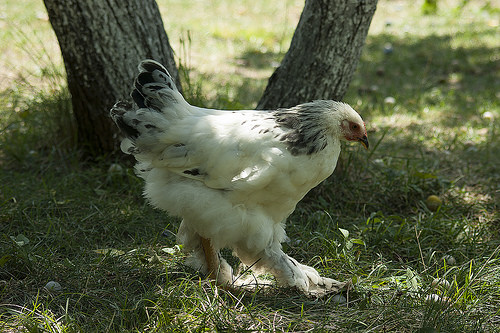<image>
Is there a tree in front of the ken? No. The tree is not in front of the ken. The spatial positioning shows a different relationship between these objects. 